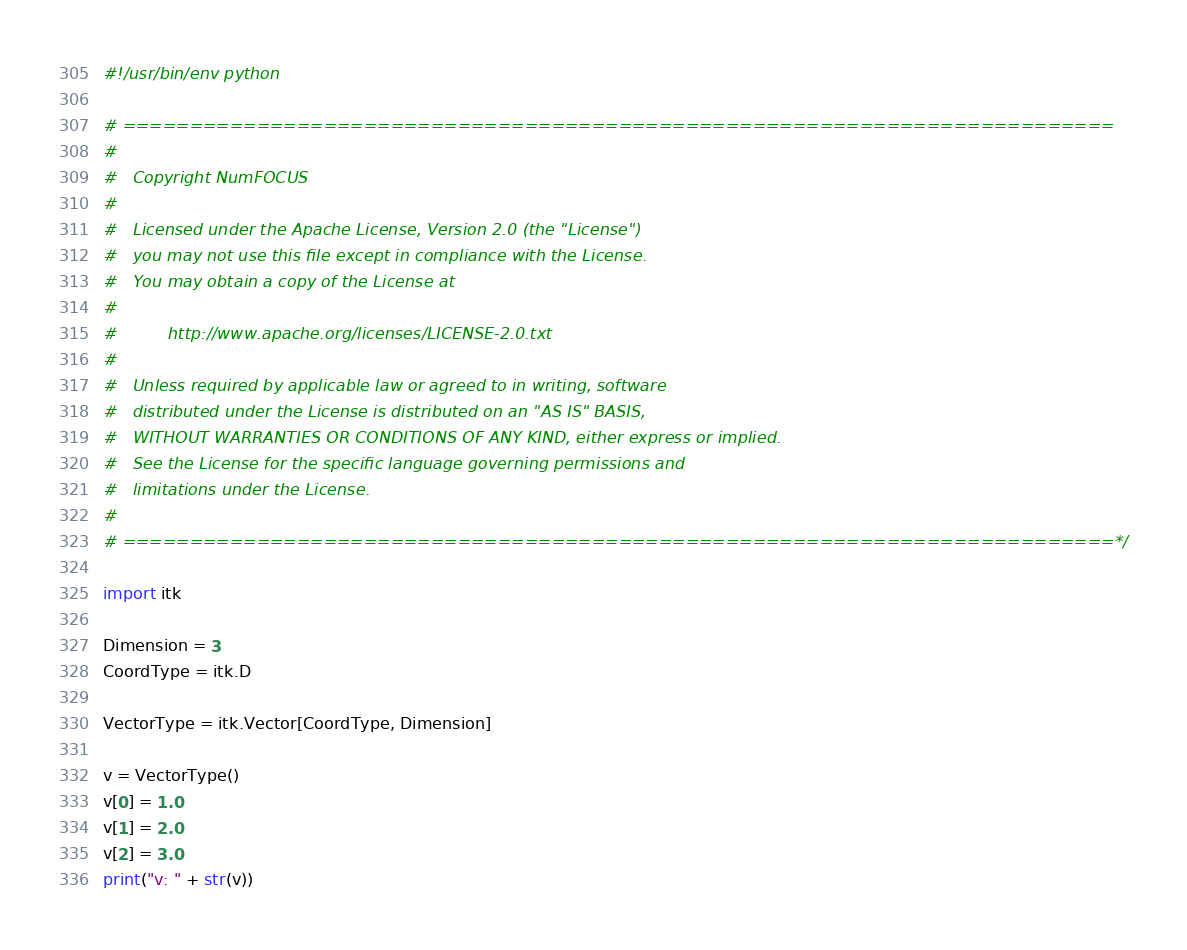Convert code to text. <code><loc_0><loc_0><loc_500><loc_500><_Python_>#!/usr/bin/env python

# ==========================================================================
#
#   Copyright NumFOCUS
#
#   Licensed under the Apache License, Version 2.0 (the "License")
#   you may not use this file except in compliance with the License.
#   You may obtain a copy of the License at
#
#          http://www.apache.org/licenses/LICENSE-2.0.txt
#
#   Unless required by applicable law or agreed to in writing, software
#   distributed under the License is distributed on an "AS IS" BASIS,
#   WITHOUT WARRANTIES OR CONDITIONS OF ANY KIND, either express or implied.
#   See the License for the specific language governing permissions and
#   limitations under the License.
#
# ==========================================================================*/

import itk

Dimension = 3
CoordType = itk.D

VectorType = itk.Vector[CoordType, Dimension]

v = VectorType()
v[0] = 1.0
v[1] = 2.0
v[2] = 3.0
print("v: " + str(v))
</code> 